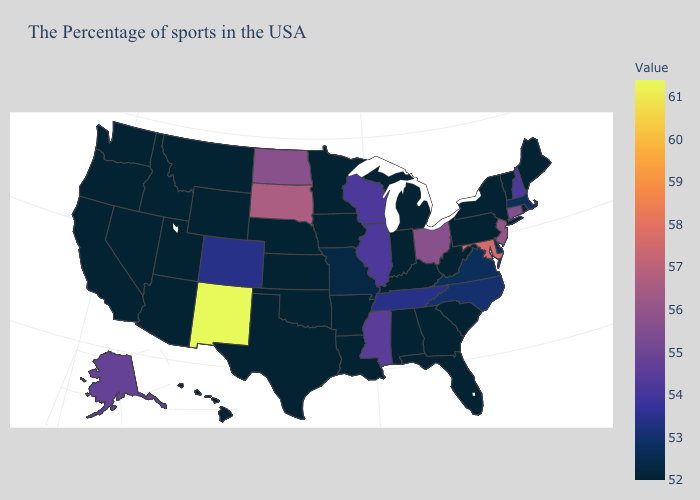Among the states that border Kentucky , which have the lowest value?
Quick response, please. West Virginia, Indiana. 